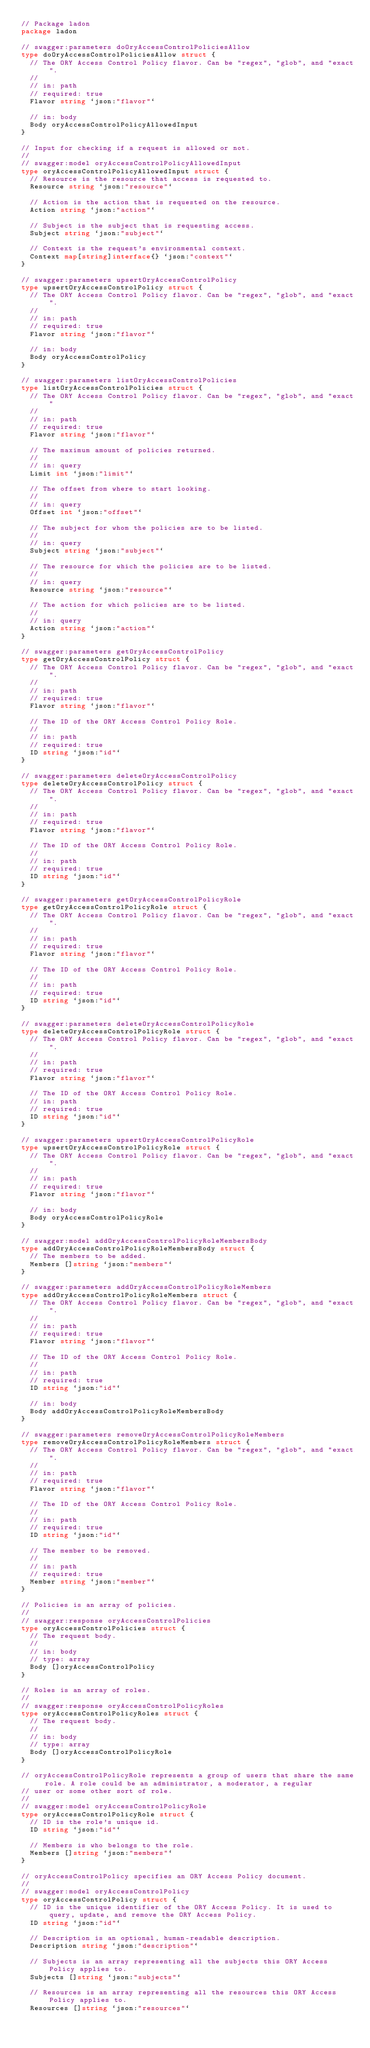<code> <loc_0><loc_0><loc_500><loc_500><_Go_>// Package ladon
package ladon

// swagger:parameters doOryAccessControlPoliciesAllow
type doOryAccessControlPoliciesAllow struct {
	// The ORY Access Control Policy flavor. Can be "regex", "glob", and "exact".
	//
	// in: path
	// required: true
	Flavor string `json:"flavor"`

	// in: body
	Body oryAccessControlPolicyAllowedInput
}

// Input for checking if a request is allowed or not.
//
// swagger:model oryAccessControlPolicyAllowedInput
type oryAccessControlPolicyAllowedInput struct {
	// Resource is the resource that access is requested to.
	Resource string `json:"resource"`

	// Action is the action that is requested on the resource.
	Action string `json:"action"`

	// Subject is the subject that is requesting access.
	Subject string `json:"subject"`

	// Context is the request's environmental context.
	Context map[string]interface{} `json:"context"`
}

// swagger:parameters upsertOryAccessControlPolicy
type upsertOryAccessControlPolicy struct {
	// The ORY Access Control Policy flavor. Can be "regex", "glob", and "exact".
	//
	// in: path
	// required: true
	Flavor string `json:"flavor"`

	// in: body
	Body oryAccessControlPolicy
}

// swagger:parameters listOryAccessControlPolicies
type listOryAccessControlPolicies struct {
	// The ORY Access Control Policy flavor. Can be "regex", "glob", and "exact"
	//
	// in: path
	// required: true
	Flavor string `json:"flavor"`

	// The maximum amount of policies returned.
	//
	// in: query
	Limit int `json:"limit"`

	// The offset from where to start looking.
	//
	// in: query
	Offset int `json:"offset"`

	// The subject for whom the policies are to be listed.
	//
	// in: query
	Subject string `json:"subject"`

	// The resource for which the policies are to be listed.
	//
	// in: query
	Resource string `json:"resource"`

	// The action for which policies are to be listed.
	//
	// in: query
	Action string `json:"action"`
}

// swagger:parameters getOryAccessControlPolicy
type getOryAccessControlPolicy struct {
	// The ORY Access Control Policy flavor. Can be "regex", "glob", and "exact".
	//
	// in: path
	// required: true
	Flavor string `json:"flavor"`

	// The ID of the ORY Access Control Policy Role.
	//
	// in: path
	// required: true
	ID string `json:"id"`
}

// swagger:parameters deleteOryAccessControlPolicy
type deleteOryAccessControlPolicy struct {
	// The ORY Access Control Policy flavor. Can be "regex", "glob", and "exact".
	//
	// in: path
	// required: true
	Flavor string `json:"flavor"`

	// The ID of the ORY Access Control Policy Role.
	//
	// in: path
	// required: true
	ID string `json:"id"`
}

// swagger:parameters getOryAccessControlPolicyRole
type getOryAccessControlPolicyRole struct {
	// The ORY Access Control Policy flavor. Can be "regex", "glob", and "exact".
	//
	// in: path
	// required: true
	Flavor string `json:"flavor"`

	// The ID of the ORY Access Control Policy Role.
	//
	// in: path
	// required: true
	ID string `json:"id"`
}

// swagger:parameters deleteOryAccessControlPolicyRole
type deleteOryAccessControlPolicyRole struct {
	// The ORY Access Control Policy flavor. Can be "regex", "glob", and "exact".
	//
	// in: path
	// required: true
	Flavor string `json:"flavor"`

	// The ID of the ORY Access Control Policy Role.
	// in: path
	// required: true
	ID string `json:"id"`
}

// swagger:parameters upsertOryAccessControlPolicyRole
type upsertOryAccessControlPolicyRole struct {
	// The ORY Access Control Policy flavor. Can be "regex", "glob", and "exact".
	//
	// in: path
	// required: true
	Flavor string `json:"flavor"`

	// in: body
	Body oryAccessControlPolicyRole
}

// swagger:model addOryAccessControlPolicyRoleMembersBody
type addOryAccessControlPolicyRoleMembersBody struct {
	// The members to be added.
	Members []string `json:"members"`
}

// swagger:parameters addOryAccessControlPolicyRoleMembers
type addOryAccessControlPolicyRoleMembers struct {
	// The ORY Access Control Policy flavor. Can be "regex", "glob", and "exact".
	//
	// in: path
	// required: true
	Flavor string `json:"flavor"`

	// The ID of the ORY Access Control Policy Role.
	//
	// in: path
	// required: true
	ID string `json:"id"`

	// in: body
	Body addOryAccessControlPolicyRoleMembersBody
}

// swagger:parameters removeOryAccessControlPolicyRoleMembers
type removeOryAccessControlPolicyRoleMembers struct {
	// The ORY Access Control Policy flavor. Can be "regex", "glob", and "exact".
	//
	// in: path
	// required: true
	Flavor string `json:"flavor"`

	// The ID of the ORY Access Control Policy Role.
	//
	// in: path
	// required: true
	ID string `json:"id"`

	// The member to be removed.
	//
	// in: path
	// required: true
	Member string `json:"member"`
}

// Policies is an array of policies.
//
// swagger:response oryAccessControlPolicies
type oryAccessControlPolicies struct {
	// The request body.
	//
	// in: body
	// type: array
	Body []oryAccessControlPolicy
}

// Roles is an array of roles.
//
// swagger:response oryAccessControlPolicyRoles
type oryAccessControlPolicyRoles struct {
	// The request body.
	//
	// in: body
	// type: array
	Body []oryAccessControlPolicyRole
}

// oryAccessControlPolicyRole represents a group of users that share the same role. A role could be an administrator, a moderator, a regular
// user or some other sort of role.
//
// swagger:model oryAccessControlPolicyRole
type oryAccessControlPolicyRole struct {
	// ID is the role's unique id.
	ID string `json:"id"`

	// Members is who belongs to the role.
	Members []string `json:"members"`
}

// oryAccessControlPolicy specifies an ORY Access Policy document.
//
// swagger:model oryAccessControlPolicy
type oryAccessControlPolicy struct {
	// ID is the unique identifier of the ORY Access Policy. It is used to query, update, and remove the ORY Access Policy.
	ID string `json:"id"`

	// Description is an optional, human-readable description.
	Description string `json:"description"`

	// Subjects is an array representing all the subjects this ORY Access Policy applies to.
	Subjects []string `json:"subjects"`

	// Resources is an array representing all the resources this ORY Access Policy applies to.
	Resources []string `json:"resources"`
</code> 